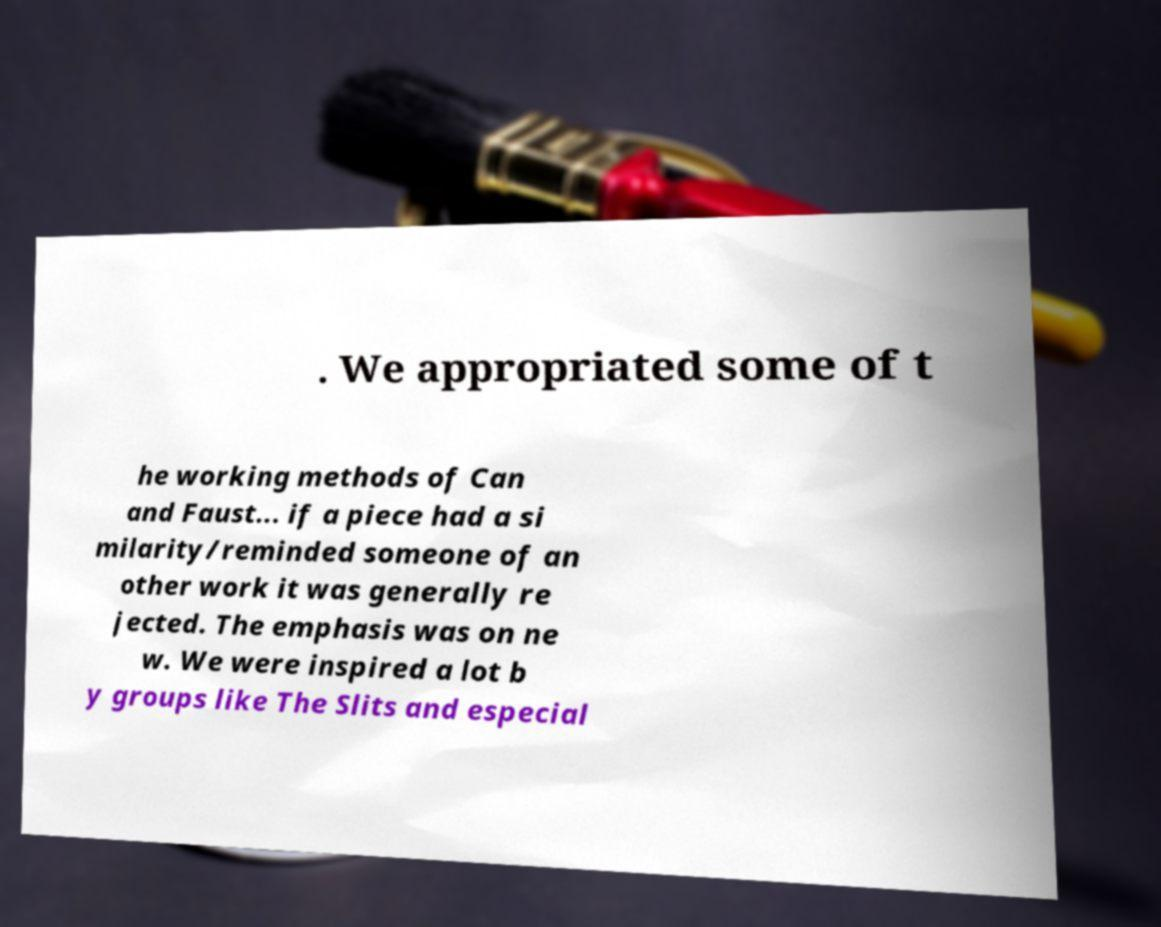For documentation purposes, I need the text within this image transcribed. Could you provide that? . We appropriated some of t he working methods of Can and Faust... if a piece had a si milarity/reminded someone of an other work it was generally re jected. The emphasis was on ne w. We were inspired a lot b y groups like The Slits and especial 